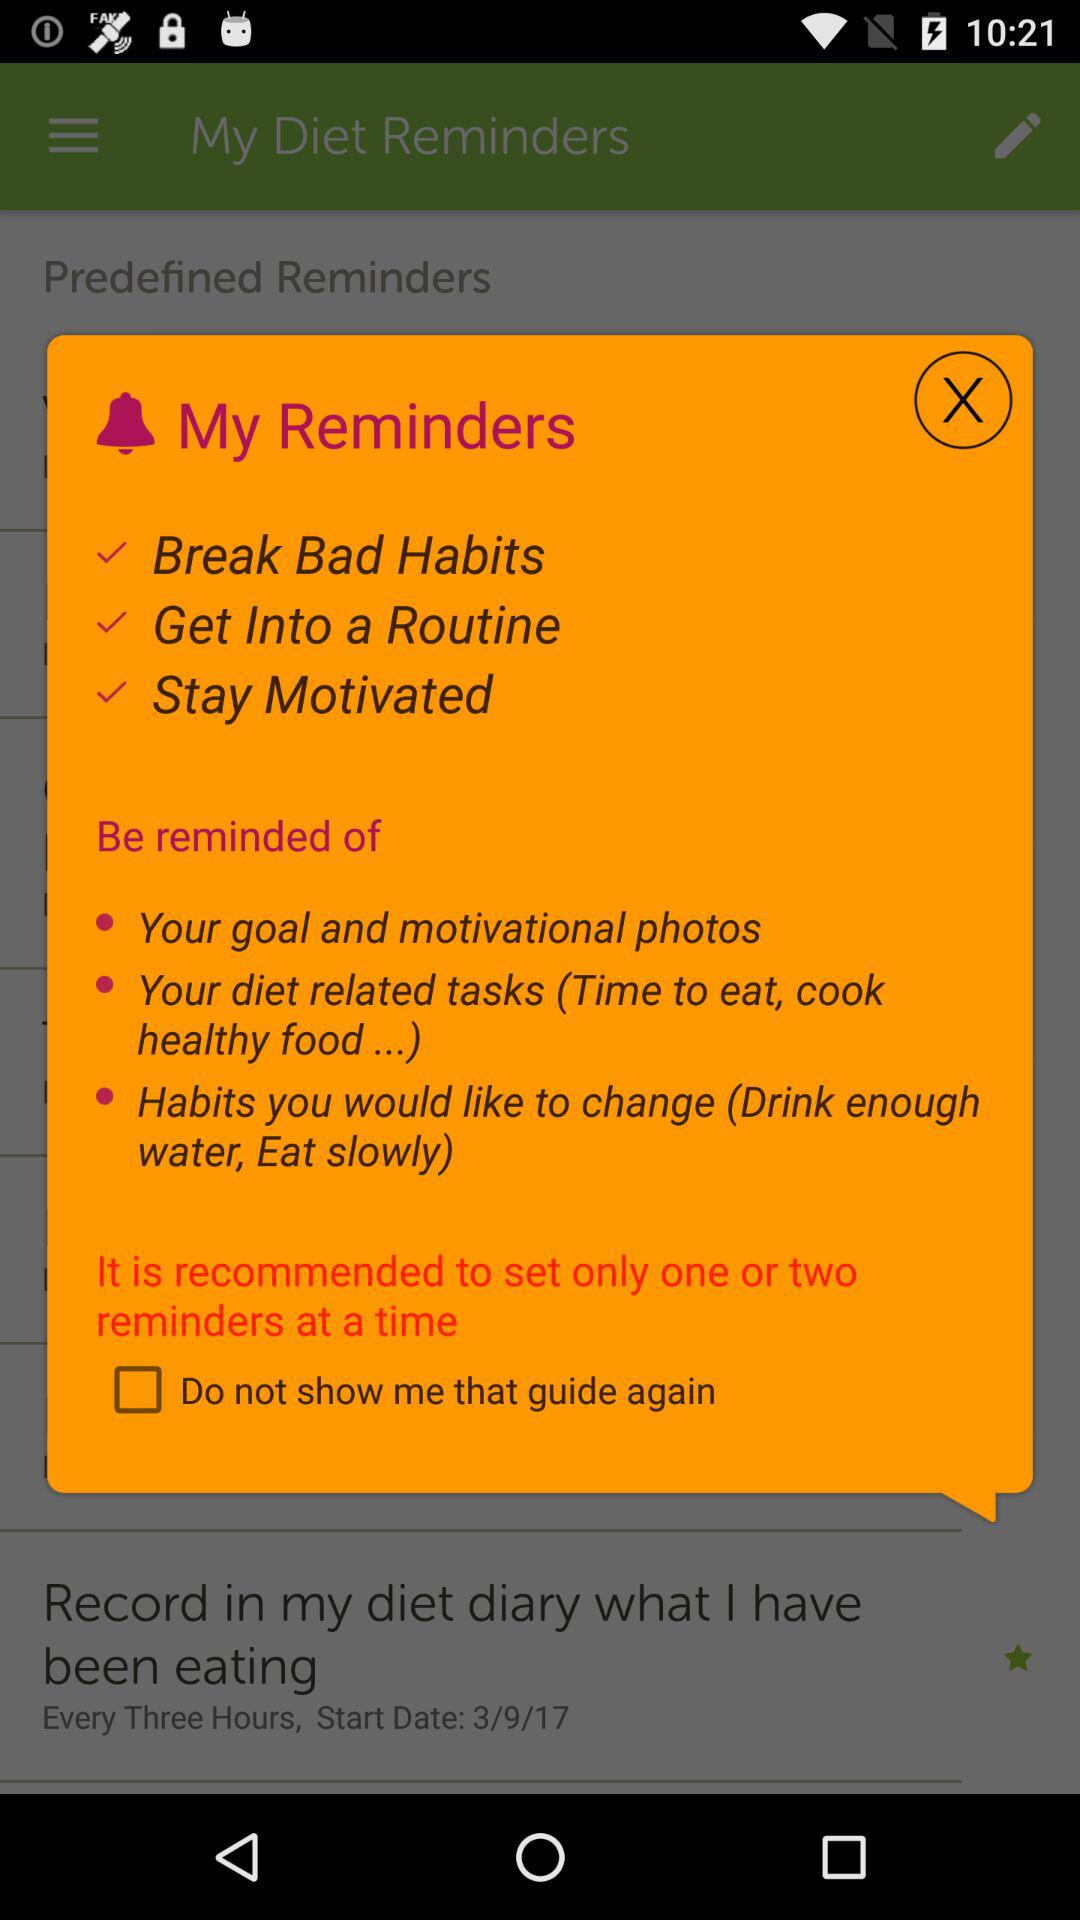What is the status of "Do not show me that guide again"? The status is "off". 